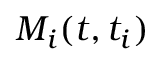Convert formula to latex. <formula><loc_0><loc_0><loc_500><loc_500>M _ { i } ( t , t _ { i } )</formula> 